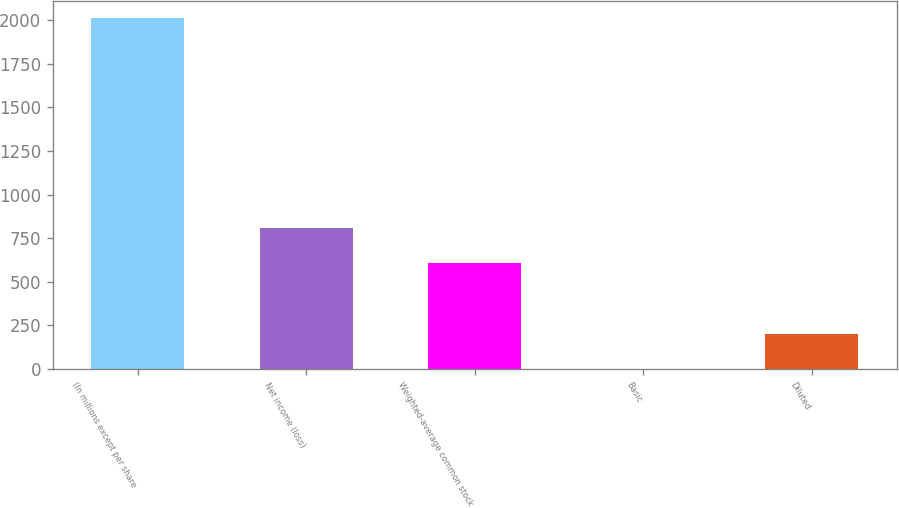Convert chart to OTSL. <chart><loc_0><loc_0><loc_500><loc_500><bar_chart><fcel>(In millions except per share<fcel>Net income (loss)<fcel>Weighted-average common stock<fcel>Basic<fcel>Diluted<nl><fcel>2010<fcel>805.24<fcel>604.45<fcel>2.08<fcel>202.87<nl></chart> 